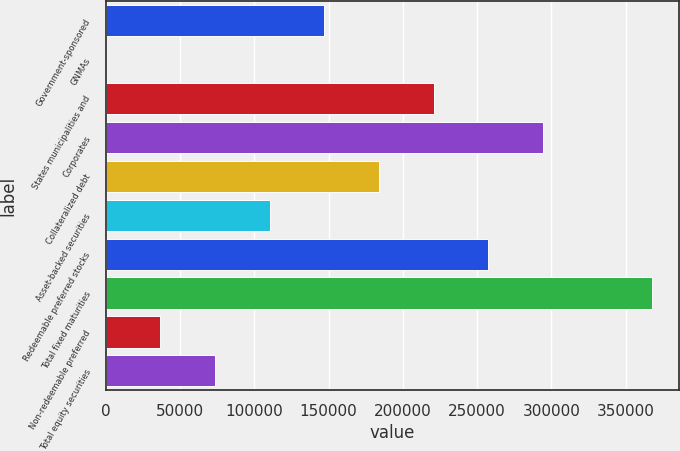Convert chart to OTSL. <chart><loc_0><loc_0><loc_500><loc_500><bar_chart><fcel>Government-sponsored<fcel>GNMAs<fcel>States municipalities and<fcel>Corporates<fcel>Collateralized debt<fcel>Asset-backed securities<fcel>Redeemable preferred stocks<fcel>Total fixed maturities<fcel>Non-redeemable preferred<fcel>Total equity securities<nl><fcel>147121<fcel>1<fcel>220681<fcel>294241<fcel>183901<fcel>110341<fcel>257461<fcel>367732<fcel>36781<fcel>73561<nl></chart> 